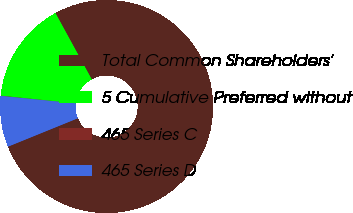Convert chart. <chart><loc_0><loc_0><loc_500><loc_500><pie_chart><fcel>Total Common Shareholders'<fcel>5 Cumulative Preferred without<fcel>465 Series C<fcel>465 Series D<nl><fcel>76.83%<fcel>15.4%<fcel>0.05%<fcel>7.72%<nl></chart> 